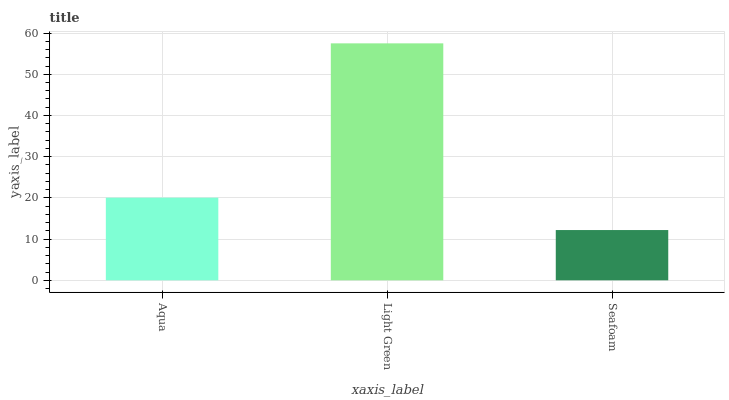Is Seafoam the minimum?
Answer yes or no. Yes. Is Light Green the maximum?
Answer yes or no. Yes. Is Light Green the minimum?
Answer yes or no. No. Is Seafoam the maximum?
Answer yes or no. No. Is Light Green greater than Seafoam?
Answer yes or no. Yes. Is Seafoam less than Light Green?
Answer yes or no. Yes. Is Seafoam greater than Light Green?
Answer yes or no. No. Is Light Green less than Seafoam?
Answer yes or no. No. Is Aqua the high median?
Answer yes or no. Yes. Is Aqua the low median?
Answer yes or no. Yes. Is Light Green the high median?
Answer yes or no. No. Is Light Green the low median?
Answer yes or no. No. 